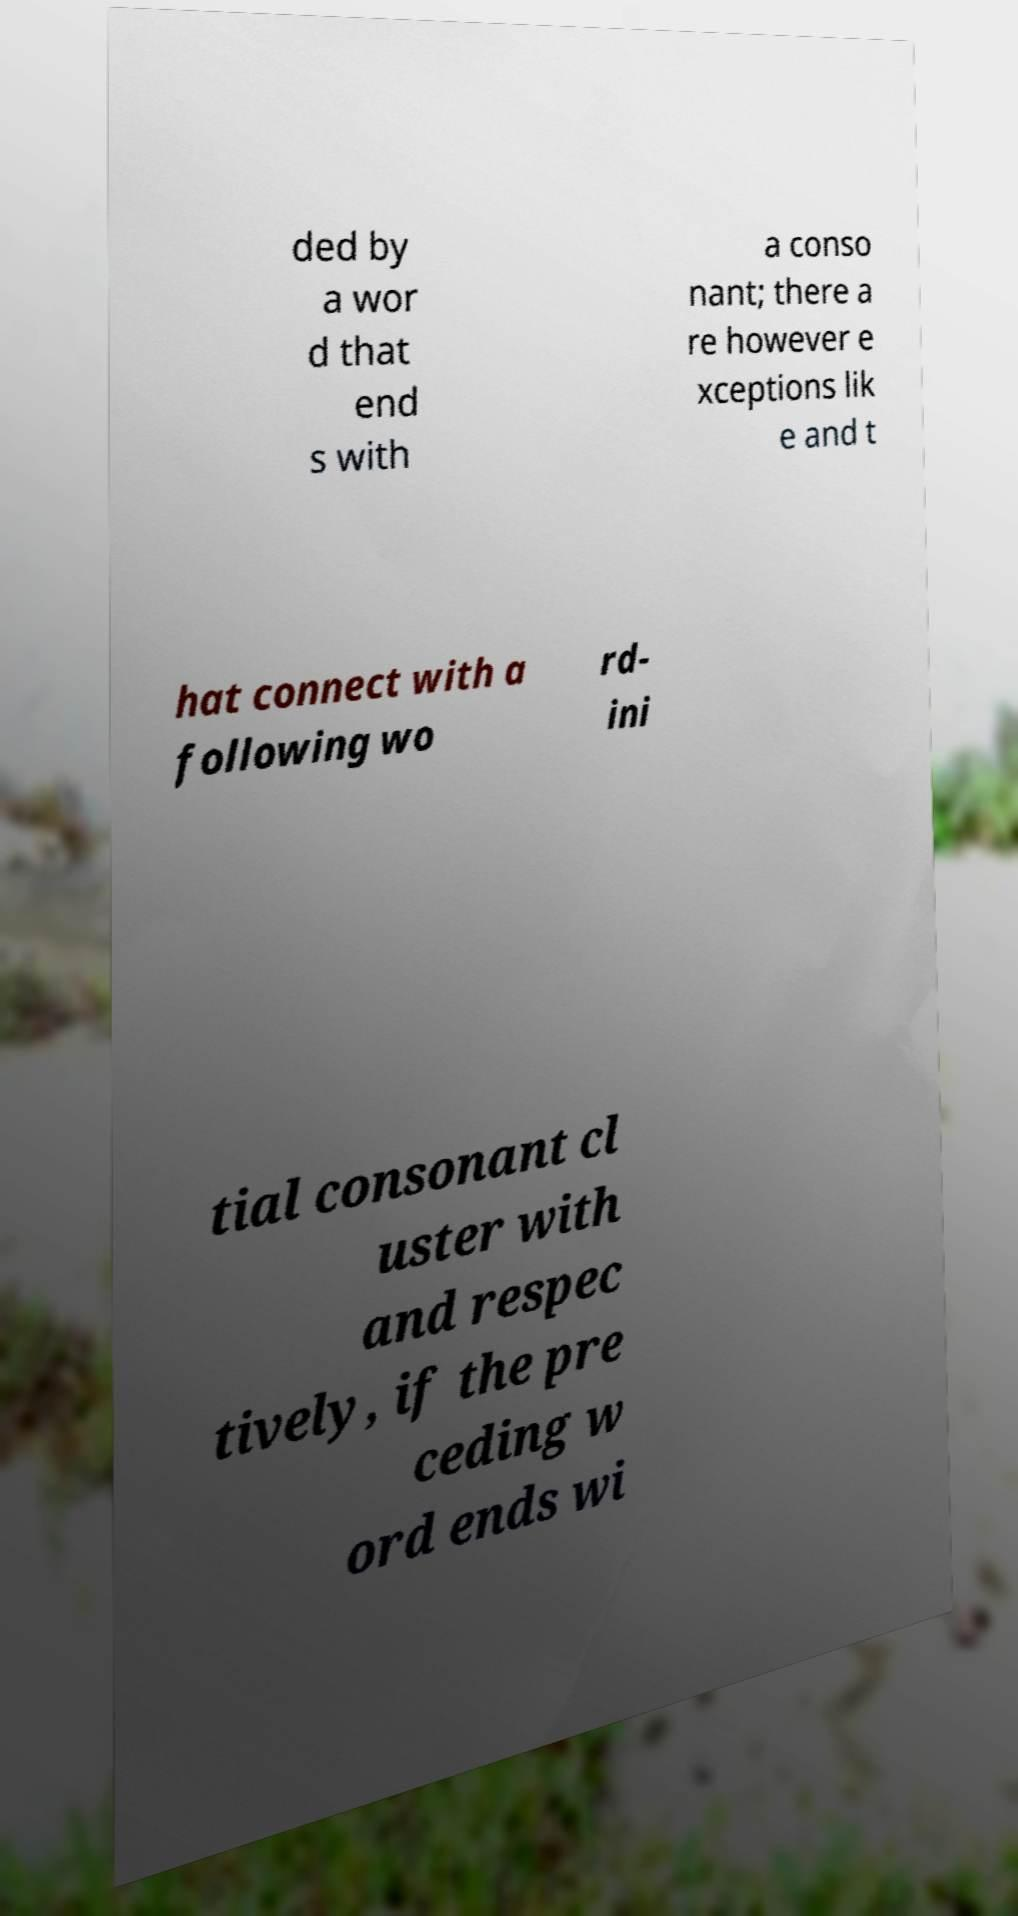For documentation purposes, I need the text within this image transcribed. Could you provide that? ded by a wor d that end s with a conso nant; there a re however e xceptions lik e and t hat connect with a following wo rd- ini tial consonant cl uster with and respec tively, if the pre ceding w ord ends wi 